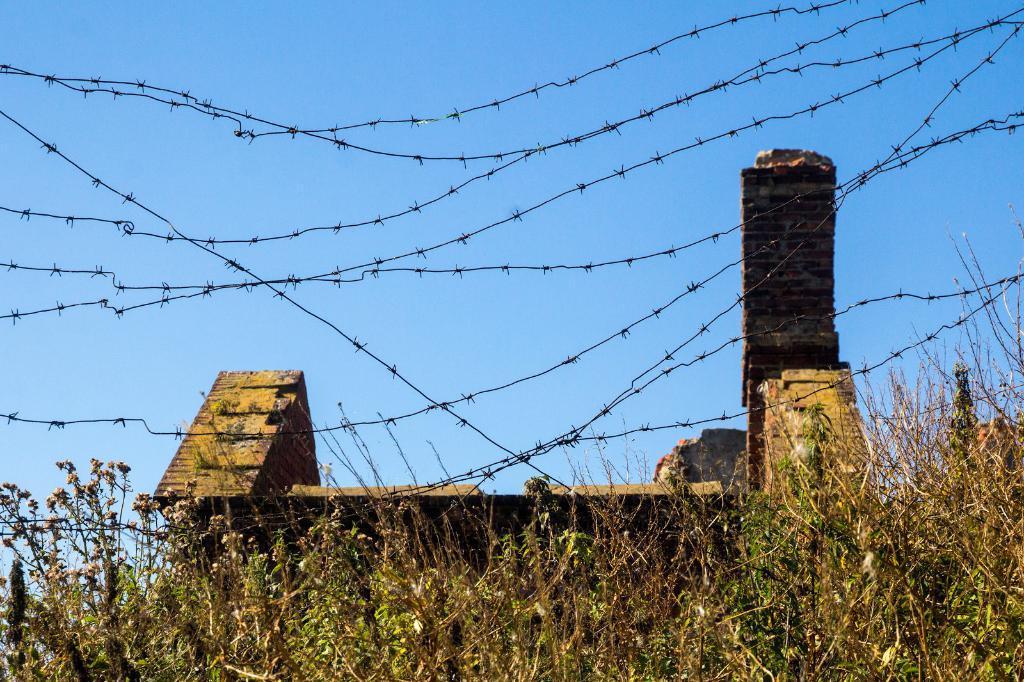In one or two sentences, can you explain what this image depicts? At the bottom of the image there are plants. In the center of the image there is a fencing. There is a house. 